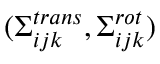Convert formula to latex. <formula><loc_0><loc_0><loc_500><loc_500>( \Sigma _ { i j k } ^ { t r a n s } , \Sigma _ { i j k } ^ { r o t } )</formula> 